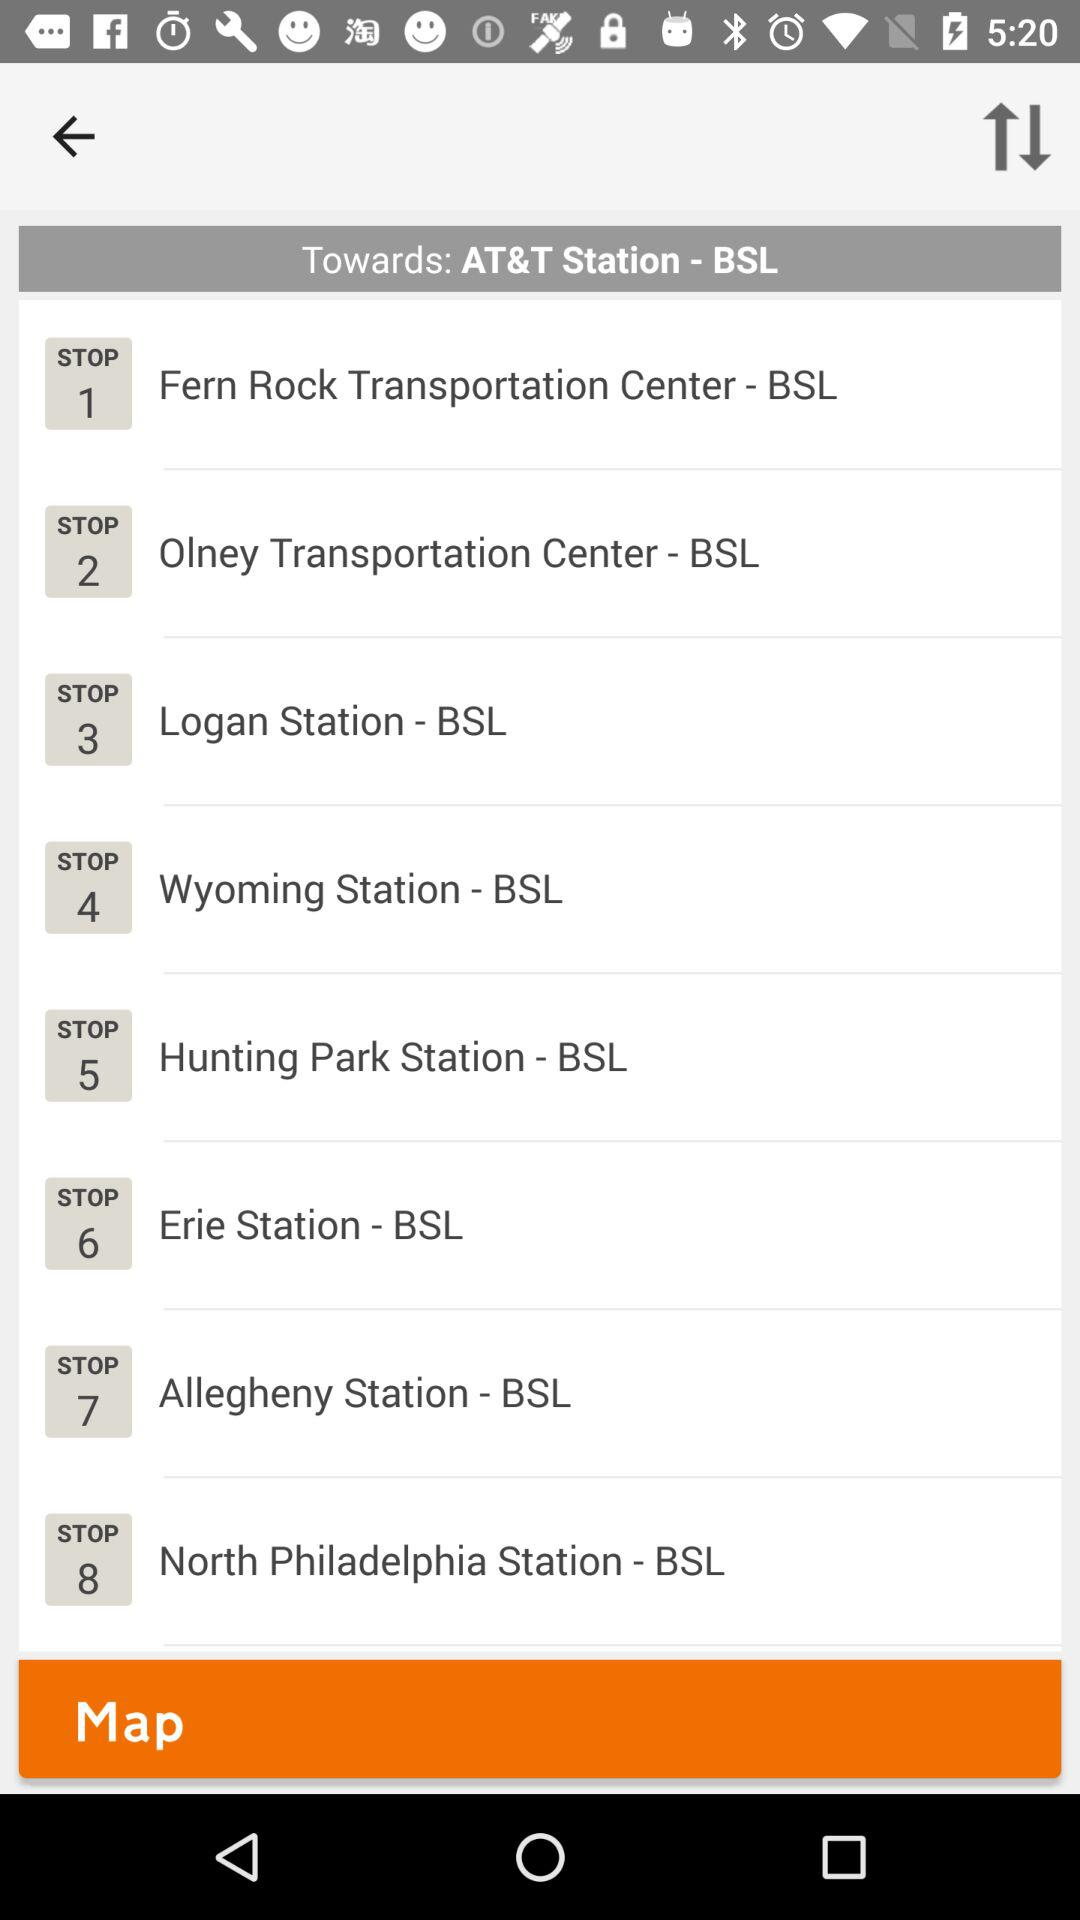Can you tell me which stop comes after Hunting Park Station on this route? The stop following Hunting Park Station on the route towards AT&T Station - BSL is Erie Station, which is stop number 6. 